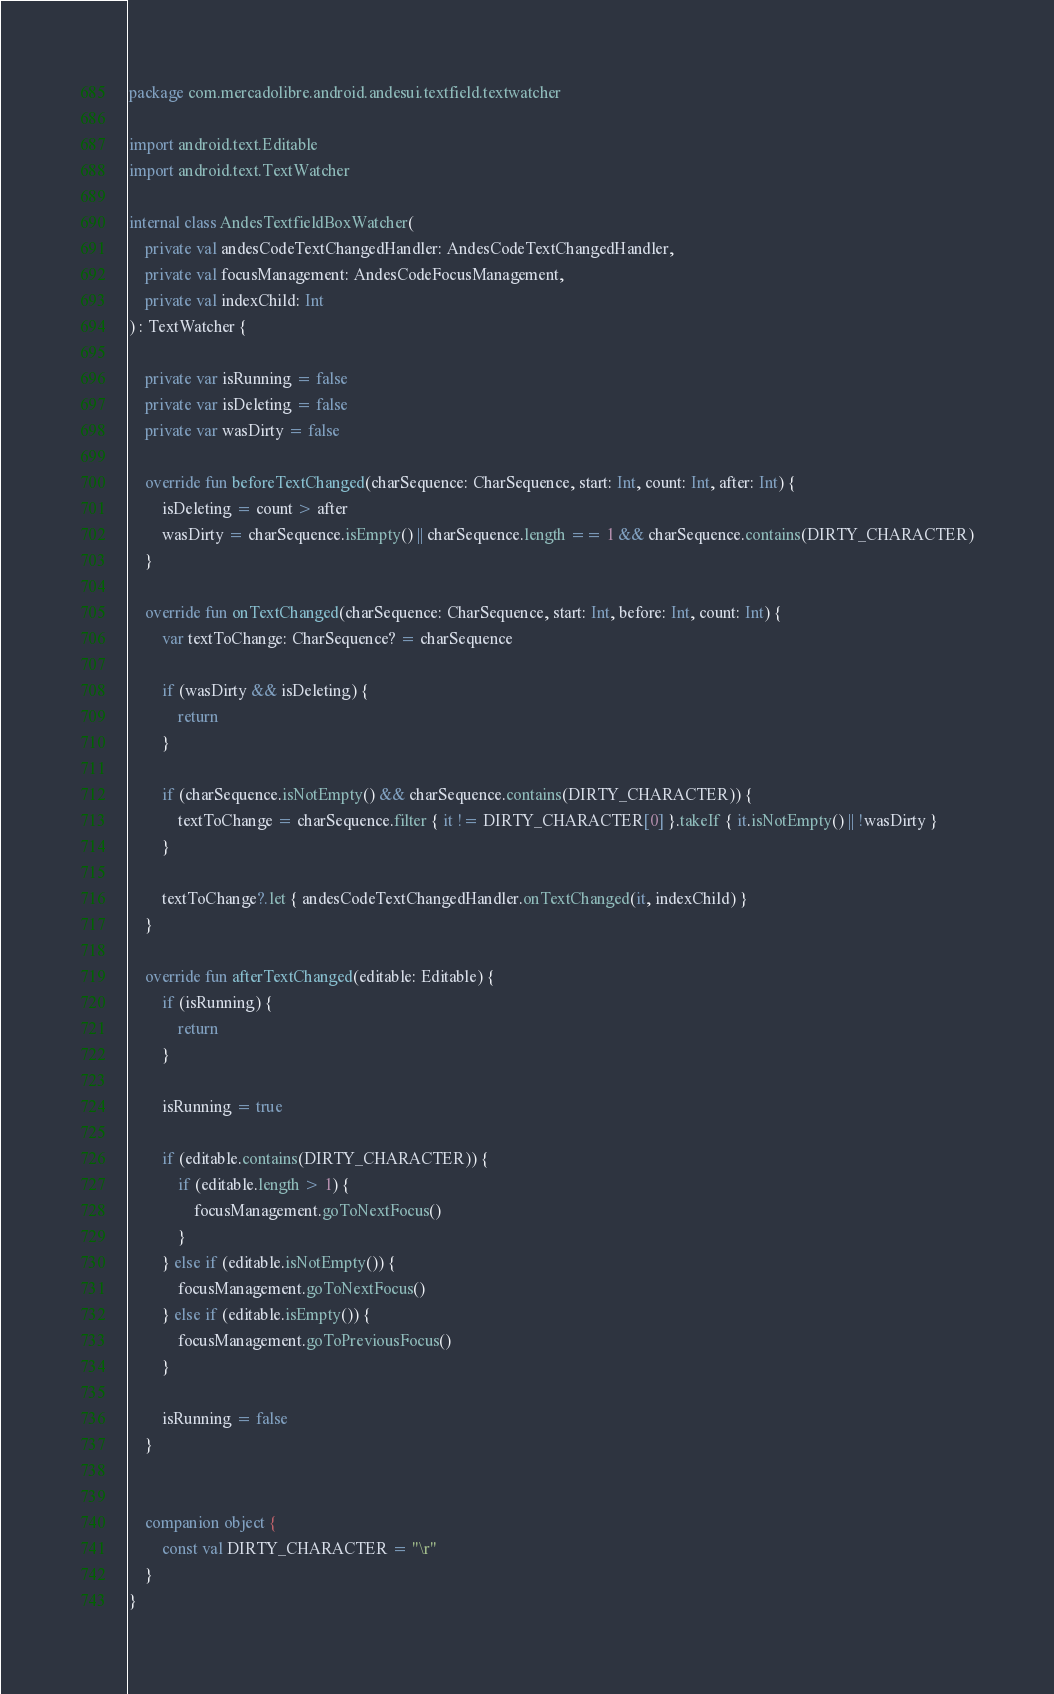Convert code to text. <code><loc_0><loc_0><loc_500><loc_500><_Kotlin_>package com.mercadolibre.android.andesui.textfield.textwatcher

import android.text.Editable
import android.text.TextWatcher

internal class AndesTextfieldBoxWatcher(
    private val andesCodeTextChangedHandler: AndesCodeTextChangedHandler,
    private val focusManagement: AndesCodeFocusManagement,
    private val indexChild: Int
) : TextWatcher {

    private var isRunning = false
    private var isDeleting = false
    private var wasDirty = false

    override fun beforeTextChanged(charSequence: CharSequence, start: Int, count: Int, after: Int) {
        isDeleting = count > after
        wasDirty = charSequence.isEmpty() || charSequence.length == 1 && charSequence.contains(DIRTY_CHARACTER)
    }

    override fun onTextChanged(charSequence: CharSequence, start: Int, before: Int, count: Int) {
        var textToChange: CharSequence? = charSequence

        if (wasDirty && isDeleting) {
            return
        }

        if (charSequence.isNotEmpty() && charSequence.contains(DIRTY_CHARACTER)) {
            textToChange = charSequence.filter { it != DIRTY_CHARACTER[0] }.takeIf { it.isNotEmpty() || !wasDirty }
        }

        textToChange?.let { andesCodeTextChangedHandler.onTextChanged(it, indexChild) }
    }

    override fun afterTextChanged(editable: Editable) {
        if (isRunning) {
            return
        }

        isRunning = true

        if (editable.contains(DIRTY_CHARACTER)) {
            if (editable.length > 1) {
                focusManagement.goToNextFocus()
            }
        } else if (editable.isNotEmpty()) {
            focusManagement.goToNextFocus()
        } else if (editable.isEmpty()) {
            focusManagement.goToPreviousFocus()
        }

        isRunning = false
    }


    companion object {
        const val DIRTY_CHARACTER = "\r"
    }
}
</code> 